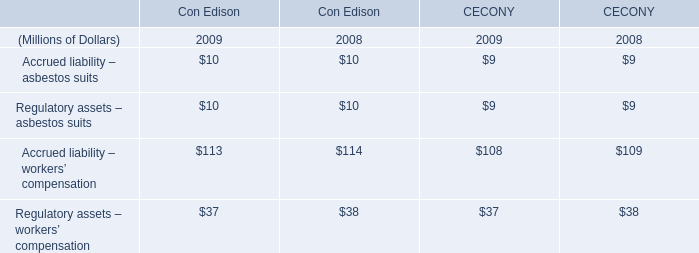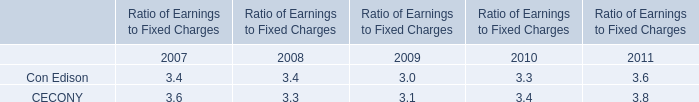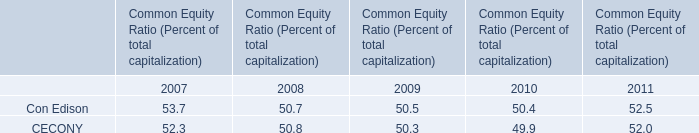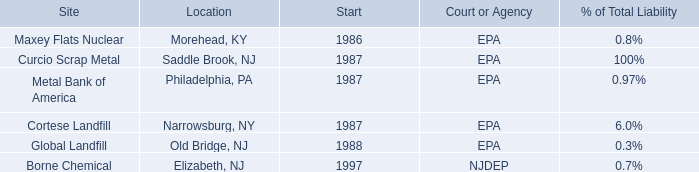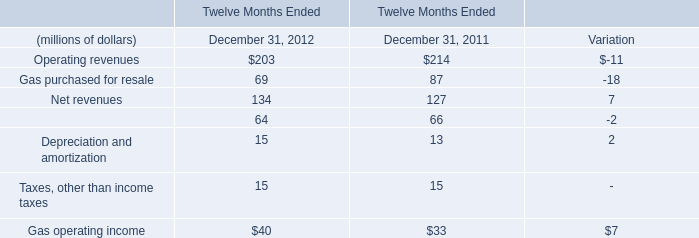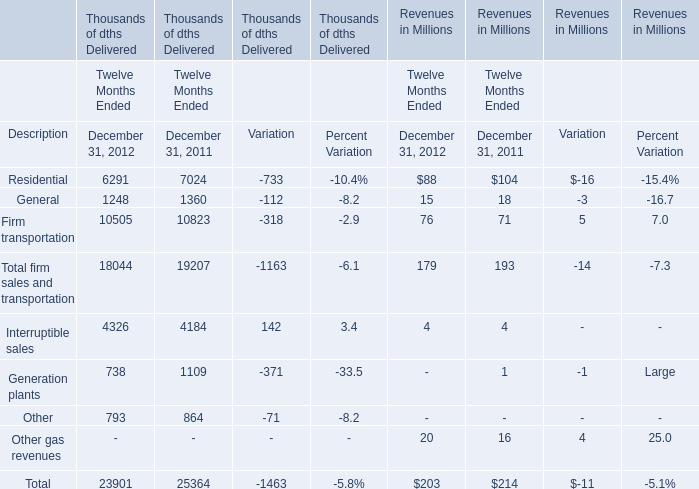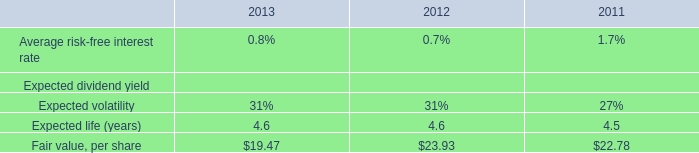What was the total amount of Gas purchased for resale, Net revenues, Operations and maintenance and Depreciation and amortization in 2012? (in million) 
Computations: (((69 + 134) + 64) + 15)
Answer: 282.0. 